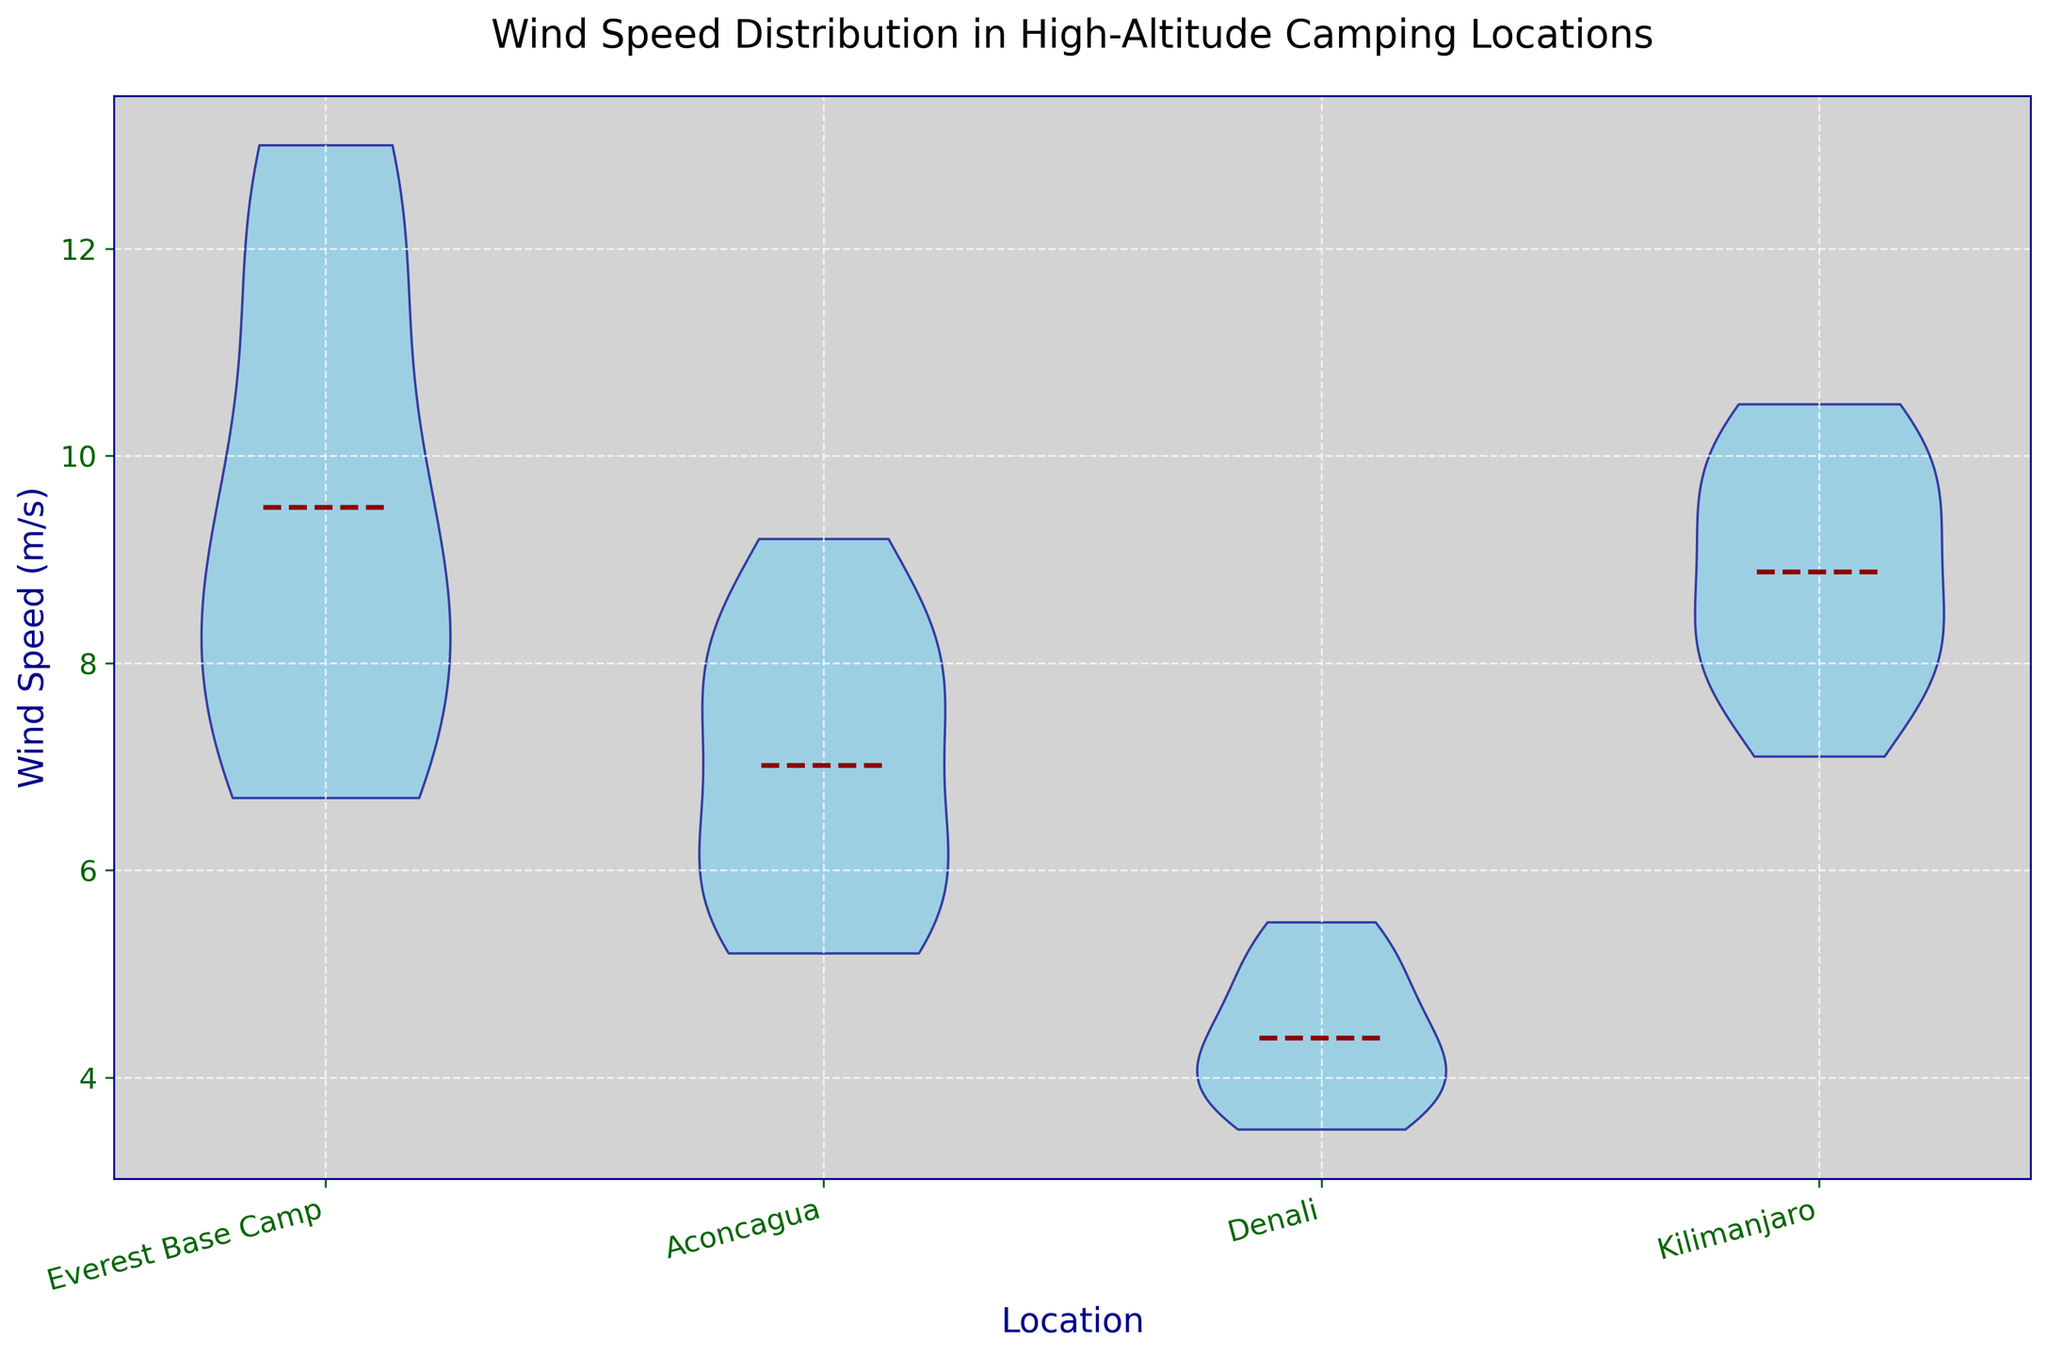What is the location with the highest average wind speed? By examining the central location of the violins, we can estimate that Everest Base Camp has the highest mean wind speed among the four locations. This is visually represented by where the mean line (dark red dashed line) is placed within each violin.
Answer: Everest Base Camp How does the spread of wind speeds at Denali compare to Kilimanjaro? The width of the violins indicates the spread of the distributions. Denali has a narrower violin compared to Kilimanjaro, suggesting a smaller spread or less variability in wind speeds at Denali.
Answer: Denali has a smaller spread Which location shows the most symmetrical distribution of wind speeds? The symmetry in the violins can be observed visually. If a violin is equally wide on both sides of its centerline, it’s more symmetrical. Denali appears to have the most symmetrical distribution.
Answer: Denali Does Everest Base Camp have any data points that might be considered outliers? Although the violin plot itself does not explicitly show outliers, the extended tails of the violins could indicate the presence of outliers. Everest Base Camp has longer tails, suggesting possible outliers in wind speed.
Answer: Yes What is the approximate range of wind speeds at Aconcagua? The vertical extent of the violin plot for Aconcagua suggests the range of wind speeds. The minimum is around 5.2 m/s and the maximum is around 9.2 m/s, giving a range of approximately 4 m/s when rounded.
Answer: Approximately 4 m/s Which location has the smallest average wind speed, and what is the estimated value? By examining the mean lines (dark red dashed lines), Denali has the smallest average wind speed, which looks to be around 4.3 m/s.
Answer: Denali, around 4.3 m/s Is there a significant difference in the width of the violin plot between Everest Base Camp and Aconcagua? Everest Base Camp's violin plot appears wider than Aconcagua’s, indicating greater variability in wind speeds at Everest Base Camp.
Answer: Yes What is the visual indication that shows the presence of multiple peaks in a wind speed distribution? Multiple peaks in a violin plot are visually represented by bulges or multiple wide sections along the vertical length of the violin. If present, these indicate multiple modes in the data.
Answer: Bulges or multiple wide sections Which location has the wind speed closest to 10 m/s most frequently? By observing the bulge or thickness around the 10 m/s mark, Kilimanjaro's violin plot shows a thicker area around this value, indicating that 10 m/s is more frequent there.
Answer: Kilimanjaro 